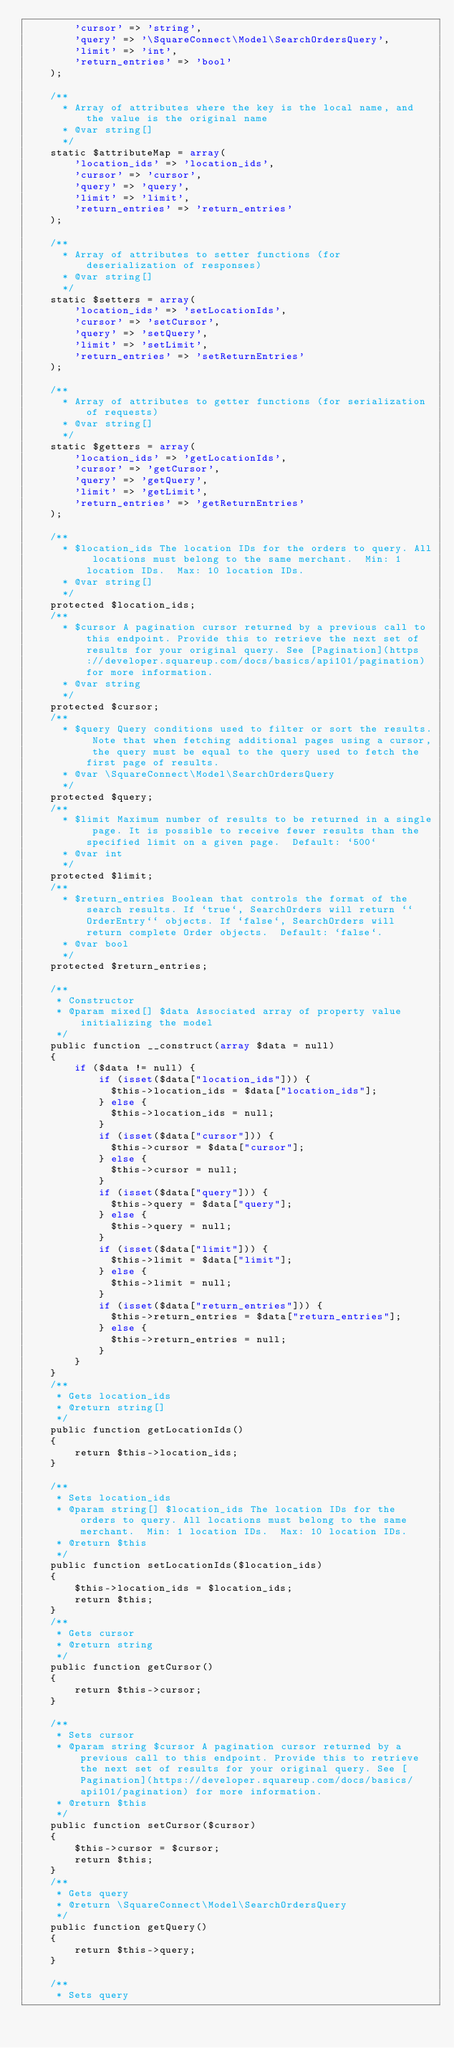Convert code to text. <code><loc_0><loc_0><loc_500><loc_500><_PHP_>        'cursor' => 'string',
        'query' => '\SquareConnect\Model\SearchOrdersQuery',
        'limit' => 'int',
        'return_entries' => 'bool'
    );
  
    /** 
      * Array of attributes where the key is the local name, and the value is the original name
      * @var string[] 
      */
    static $attributeMap = array(
        'location_ids' => 'location_ids',
        'cursor' => 'cursor',
        'query' => 'query',
        'limit' => 'limit',
        'return_entries' => 'return_entries'
    );
  
    /**
      * Array of attributes to setter functions (for deserialization of responses)
      * @var string[]
      */
    static $setters = array(
        'location_ids' => 'setLocationIds',
        'cursor' => 'setCursor',
        'query' => 'setQuery',
        'limit' => 'setLimit',
        'return_entries' => 'setReturnEntries'
    );
  
    /**
      * Array of attributes to getter functions (for serialization of requests)
      * @var string[]
      */
    static $getters = array(
        'location_ids' => 'getLocationIds',
        'cursor' => 'getCursor',
        'query' => 'getQuery',
        'limit' => 'getLimit',
        'return_entries' => 'getReturnEntries'
    );
  
    /**
      * $location_ids The location IDs for the orders to query. All locations must belong to the same merchant.  Min: 1 location IDs.  Max: 10 location IDs.
      * @var string[]
      */
    protected $location_ids;
    /**
      * $cursor A pagination cursor returned by a previous call to this endpoint. Provide this to retrieve the next set of results for your original query. See [Pagination](https://developer.squareup.com/docs/basics/api101/pagination) for more information.
      * @var string
      */
    protected $cursor;
    /**
      * $query Query conditions used to filter or sort the results. Note that when fetching additional pages using a cursor, the query must be equal to the query used to fetch the first page of results.
      * @var \SquareConnect\Model\SearchOrdersQuery
      */
    protected $query;
    /**
      * $limit Maximum number of results to be returned in a single page. It is possible to receive fewer results than the specified limit on a given page.  Default: `500`
      * @var int
      */
    protected $limit;
    /**
      * $return_entries Boolean that controls the format of the search results. If `true`, SearchOrders will return ``OrderEntry`` objects. If `false`, SearchOrders will return complete Order objects.  Default: `false`.
      * @var bool
      */
    protected $return_entries;

    /**
     * Constructor
     * @param mixed[] $data Associated array of property value initializing the model
     */
    public function __construct(array $data = null)
    {
        if ($data != null) {
            if (isset($data["location_ids"])) {
              $this->location_ids = $data["location_ids"];
            } else {
              $this->location_ids = null;
            }
            if (isset($data["cursor"])) {
              $this->cursor = $data["cursor"];
            } else {
              $this->cursor = null;
            }
            if (isset($data["query"])) {
              $this->query = $data["query"];
            } else {
              $this->query = null;
            }
            if (isset($data["limit"])) {
              $this->limit = $data["limit"];
            } else {
              $this->limit = null;
            }
            if (isset($data["return_entries"])) {
              $this->return_entries = $data["return_entries"];
            } else {
              $this->return_entries = null;
            }
        }
    }
    /**
     * Gets location_ids
     * @return string[]
     */
    public function getLocationIds()
    {
        return $this->location_ids;
    }
  
    /**
     * Sets location_ids
     * @param string[] $location_ids The location IDs for the orders to query. All locations must belong to the same merchant.  Min: 1 location IDs.  Max: 10 location IDs.
     * @return $this
     */
    public function setLocationIds($location_ids)
    {
        $this->location_ids = $location_ids;
        return $this;
    }
    /**
     * Gets cursor
     * @return string
     */
    public function getCursor()
    {
        return $this->cursor;
    }
  
    /**
     * Sets cursor
     * @param string $cursor A pagination cursor returned by a previous call to this endpoint. Provide this to retrieve the next set of results for your original query. See [Pagination](https://developer.squareup.com/docs/basics/api101/pagination) for more information.
     * @return $this
     */
    public function setCursor($cursor)
    {
        $this->cursor = $cursor;
        return $this;
    }
    /**
     * Gets query
     * @return \SquareConnect\Model\SearchOrdersQuery
     */
    public function getQuery()
    {
        return $this->query;
    }
  
    /**
     * Sets query</code> 